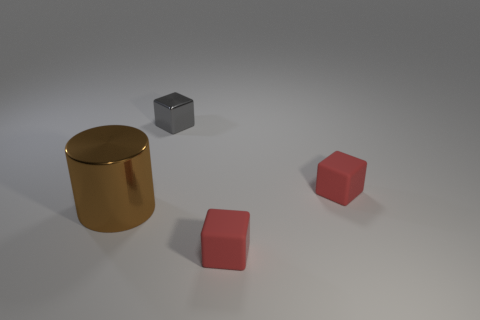Subtract all matte blocks. How many blocks are left? 1 Add 3 small gray objects. How many objects exist? 7 Subtract all gray cubes. How many cubes are left? 2 Subtract all cylinders. How many objects are left? 3 Subtract all yellow cylinders. Subtract all blue blocks. How many cylinders are left? 1 Subtract all cyan cylinders. How many red blocks are left? 2 Subtract all blocks. Subtract all big metallic cylinders. How many objects are left? 0 Add 2 red rubber cubes. How many red rubber cubes are left? 4 Add 1 small yellow metal things. How many small yellow metal things exist? 1 Subtract 0 purple blocks. How many objects are left? 4 